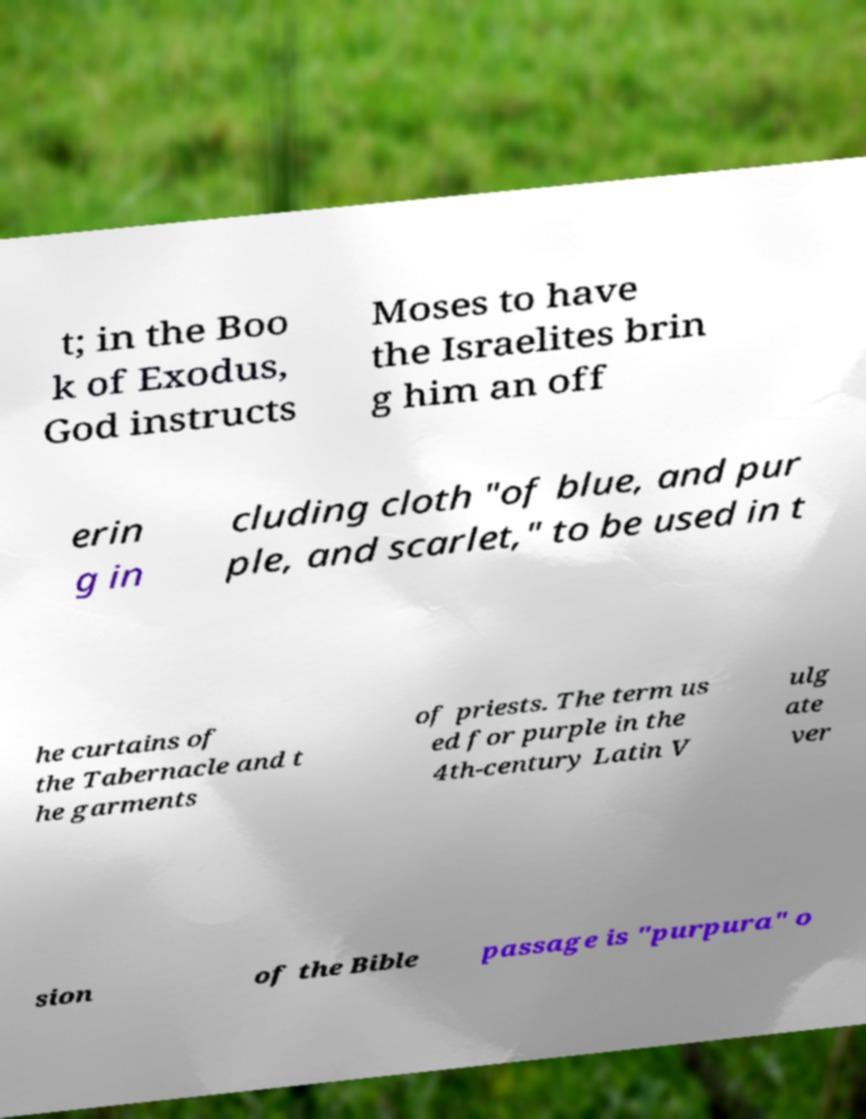Please read and relay the text visible in this image. What does it say? t; in the Boo k of Exodus, God instructs Moses to have the Israelites brin g him an off erin g in cluding cloth "of blue, and pur ple, and scarlet," to be used in t he curtains of the Tabernacle and t he garments of priests. The term us ed for purple in the 4th-century Latin V ulg ate ver sion of the Bible passage is "purpura" o 